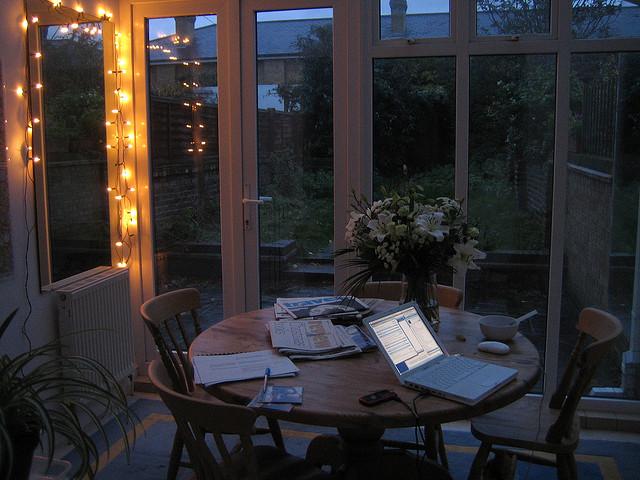Is it sunny out?
Quick response, please. No. Is it a sunny day?
Short answer required. No. Is the door open or closed?
Write a very short answer. Closed. Do the windows have grids?
Give a very brief answer. No. Where are the flowers located?
Quick response, please. Table. Is the a laptop on the table?
Concise answer only. Yes. How many chairs are at the table?
Concise answer only. 4. What time of day is it?
Quick response, please. Evening. Is there a fence?
Keep it brief. No. 